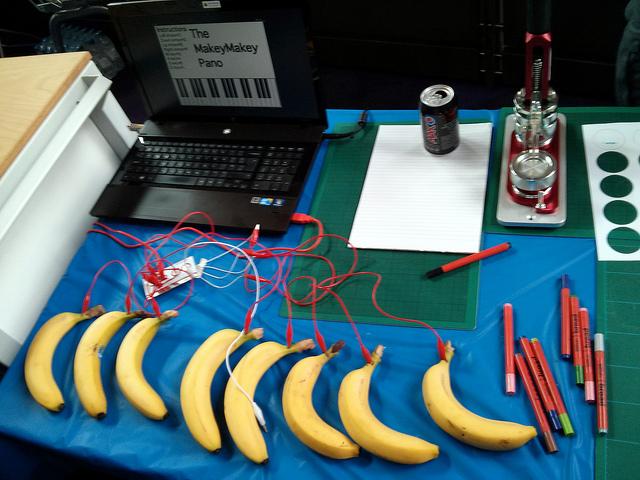How many bananas are on the table?
Write a very short answer. 8. Are any of the items seen good for painting?
Short answer required. No. How many markers are there?
Keep it brief. 9. What are these objects used for?
Concise answer only. Eating. What color are the bananas?
Quick response, please. Yellow. 